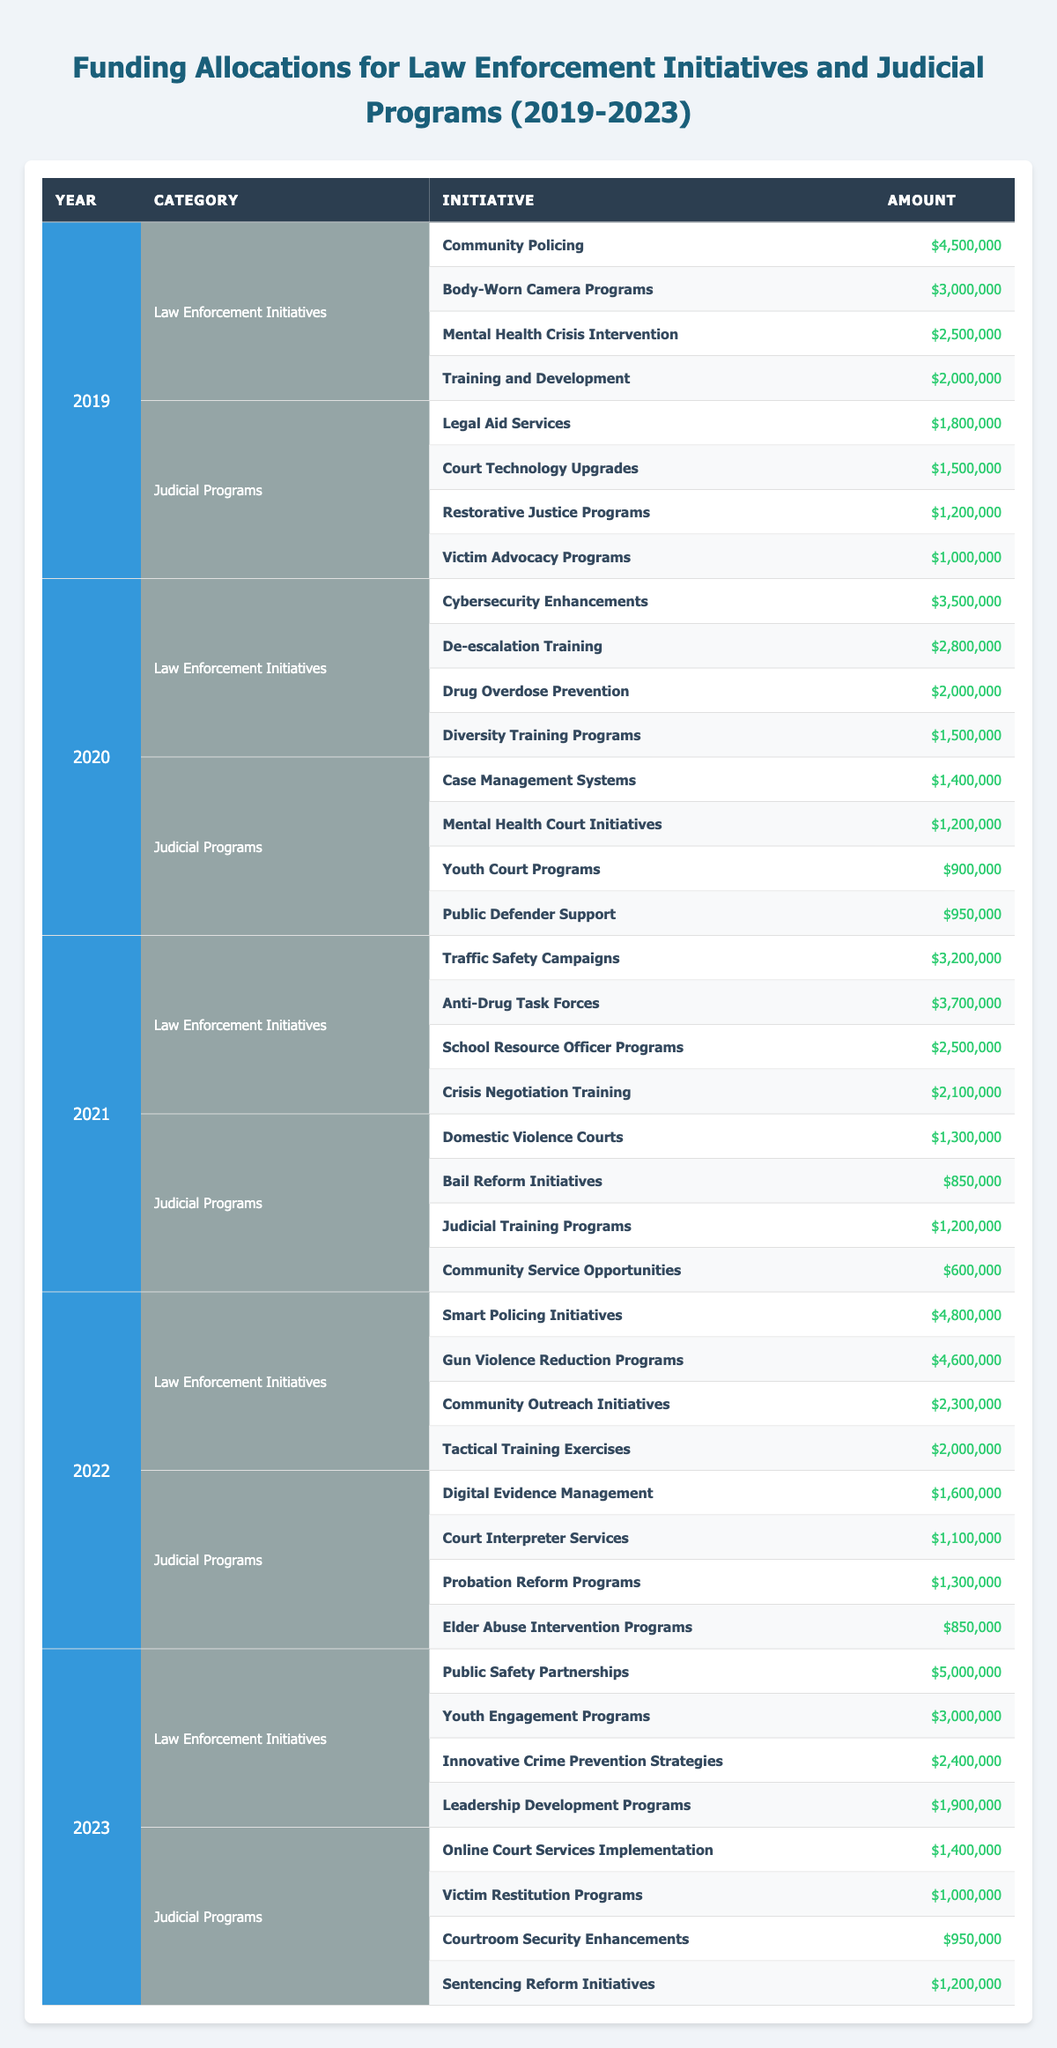What was the total funding allocated to Law Enforcement Initiatives in 2020? In 2020, the individual allocations for Law Enforcement Initiatives were: Cybersecurity Enhancements ($3,500,000), De-escalation Training ($2,800,000), Drug Overdose Prevention ($2,000,000), and Diversity Training Programs ($1,500,000). Adding these amounts together: $3,500,000 + $2,800,000 + $2,000,000 + $1,500,000 = $10,800,000.
Answer: 10,800,000 Which year had the highest funding for Judicial Programs? To find the year with the highest funding for Judicial Programs, we check each year’s total from the table. The amounts are as follows: 2019 - $4,700,000, 2020 - $4,450,000, 2021 - $3,950,000, 2022 - $4,850,000, and 2023 - $4,550,000. The highest funding is $4,850,000 in 2022.
Answer: 2022 Did funding for Law Enforcement Initiatives increase from 2021 to 2022? In 2021, Law Enforcement Initiatives received $9,800,000 and in 2022, they received $11,400,000. Since $11,400,000 is greater than $9,800,000, it confirms that funding did indeed increase.
Answer: Yes What is the average funding for Law Enforcement Initiatives over the five years? To calculate the average, we must sum the total funding for each Law Enforcement Initiative across all five years: 2019 - $14,500,000, 2020 - $10,800,000, 2021 - $9,800,000, 2022 - $11,400,000, and 2023 - $11,490,000. Total = $14,500,000 + $10,800,000 + $9,800,000 + $11,400,000 + $11,490,000 = $58,990,000. There are 5 years, so we divide $58,990,000 by 5, which gives $11,798,000.
Answer: 11,798,000 Which individual initiative received the least funding in the year 2021? By reviewing the individual allocations for initiatives in 2021, we find the following: Domestic Violence Courts ($1,300,000), Bail Reform Initiatives ($850,000), Judicial Training Programs ($1,200,000), and Community Service Opportunities ($600,000). The lowest funding amount is for Community Service Opportunities at $600,000.
Answer: Community Service Opportunities 